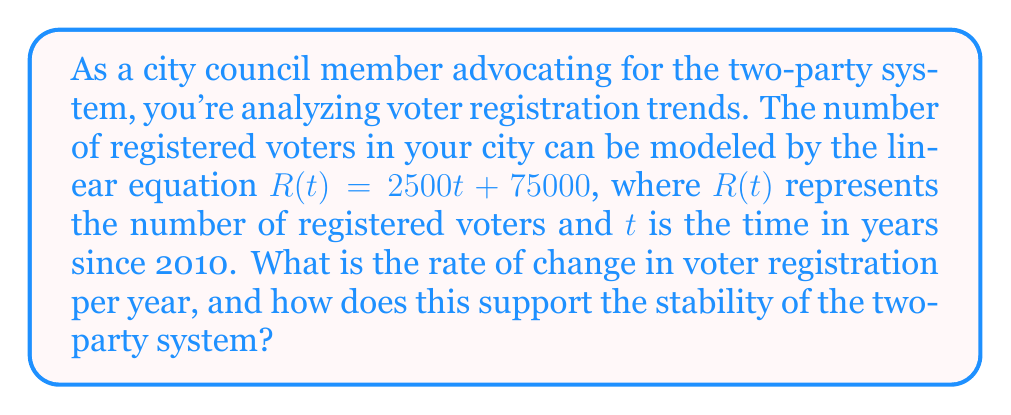Can you solve this math problem? To determine the rate of change in voter registration over time, we need to analyze the given linear equation:

$R(t) = 2500t + 75000$

In a linear equation of the form $y = mx + b$, the coefficient $m$ represents the slope of the line, which is equivalent to the rate of change.

In our equation:
$m = 2500$

This means that the number of registered voters is increasing by 2500 per year.

To interpret this in the context of the two-party system:

1. A steady increase in voter registration suggests growing civic engagement, which is crucial for a healthy democracy.

2. The consistent rate of change (2500 per year) indicates stability in the growth of the electorate, which can be seen as a positive sign for the established two-party system.

3. This gradual increase allows both major parties to adapt their strategies and messaging over time, rather than facing sudden, destabilizing shifts in the voter base.

4. A steady growth rate gives both parties equal opportunity to appeal to new voters, maintaining the balance of the two-party system.

5. The linear growth suggests that the city's political landscape is evolving in a predictable manner, which supports the argument that the two-party system provides stability.
Answer: The rate of change in voter registration is 2500 voters per year, supporting the stability of the two-party system by providing a steady, predictable growth in the electorate. 